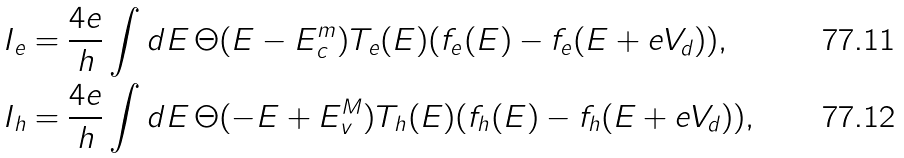<formula> <loc_0><loc_0><loc_500><loc_500>I _ { e } & = \frac { 4 e } { h } \int d E \, \Theta ( E - E _ { c } ^ { m } ) T _ { e } ( E ) ( f _ { e } ( E ) - f _ { e } ( E + e V _ { d } ) ) , \\ I _ { h } & = \frac { 4 e } { h } \int d E \, \Theta ( - E + E _ { v } ^ { M } ) T _ { h } ( E ) ( f _ { h } ( E ) - f _ { h } ( E + e V _ { d } ) ) ,</formula> 